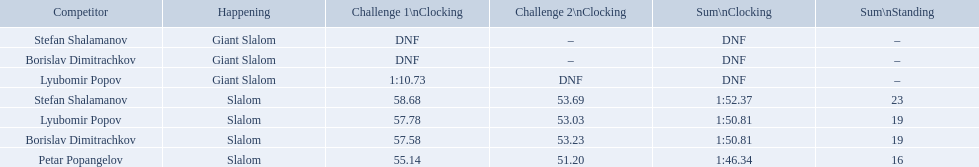What are all the competitions lyubomir popov competed in? Lyubomir Popov, Lyubomir Popov. Of those, which were giant slalom races? Giant Slalom. What was his time in race 1? 1:10.73. 